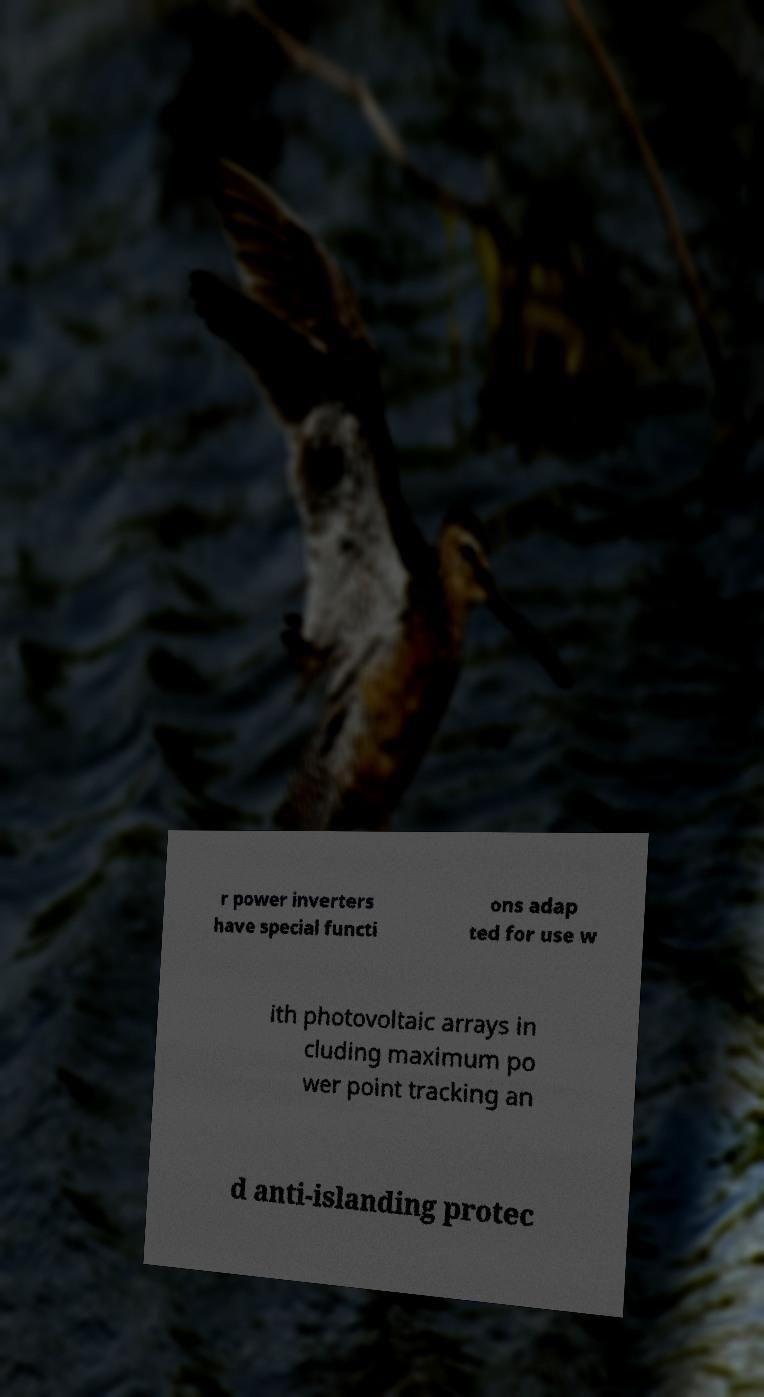Can you read and provide the text displayed in the image?This photo seems to have some interesting text. Can you extract and type it out for me? r power inverters have special functi ons adap ted for use w ith photovoltaic arrays in cluding maximum po wer point tracking an d anti-islanding protec 